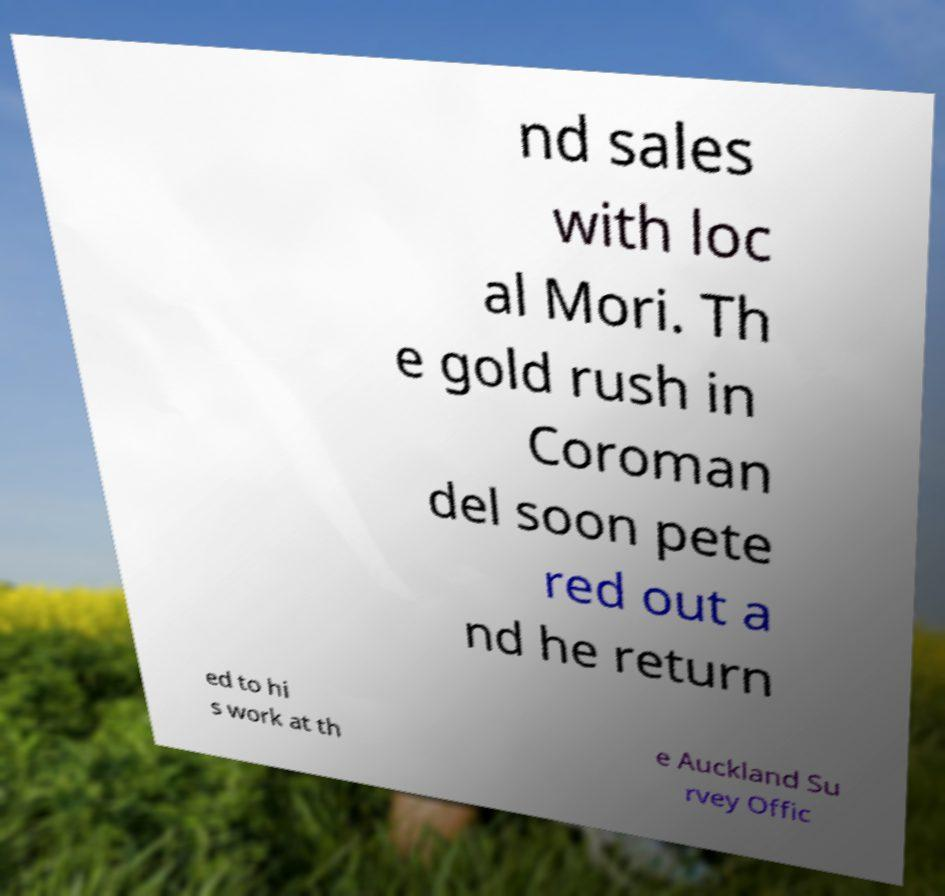Can you accurately transcribe the text from the provided image for me? nd sales with loc al Mori. Th e gold rush in Coroman del soon pete red out a nd he return ed to hi s work at th e Auckland Su rvey Offic 